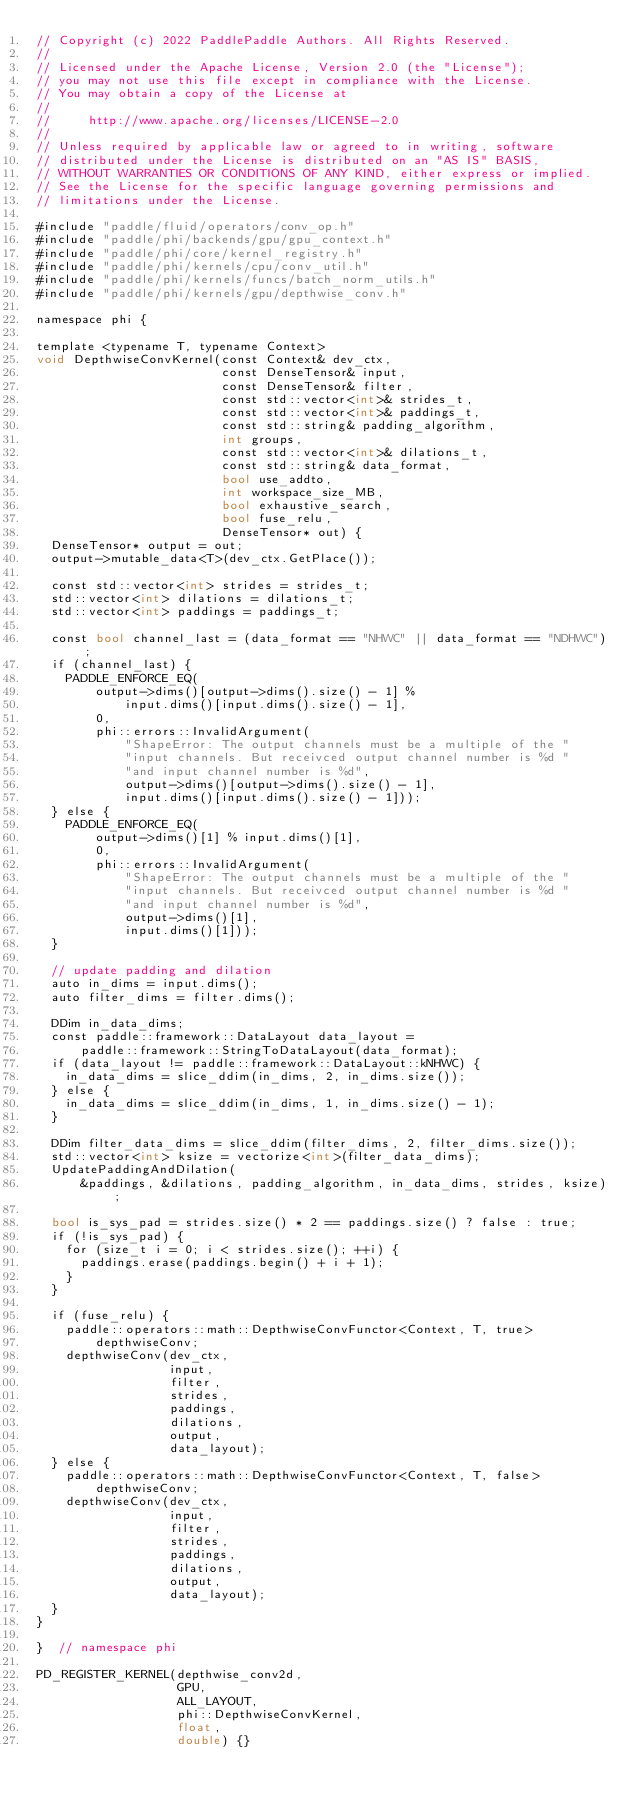<code> <loc_0><loc_0><loc_500><loc_500><_Cuda_>// Copyright (c) 2022 PaddlePaddle Authors. All Rights Reserved.
//
// Licensed under the Apache License, Version 2.0 (the "License");
// you may not use this file except in compliance with the License.
// You may obtain a copy of the License at
//
//     http://www.apache.org/licenses/LICENSE-2.0
//
// Unless required by applicable law or agreed to in writing, software
// distributed under the License is distributed on an "AS IS" BASIS,
// WITHOUT WARRANTIES OR CONDITIONS OF ANY KIND, either express or implied.
// See the License for the specific language governing permissions and
// limitations under the License.

#include "paddle/fluid/operators/conv_op.h"
#include "paddle/phi/backends/gpu/gpu_context.h"
#include "paddle/phi/core/kernel_registry.h"
#include "paddle/phi/kernels/cpu/conv_util.h"
#include "paddle/phi/kernels/funcs/batch_norm_utils.h"
#include "paddle/phi/kernels/gpu/depthwise_conv.h"

namespace phi {

template <typename T, typename Context>
void DepthwiseConvKernel(const Context& dev_ctx,
                         const DenseTensor& input,
                         const DenseTensor& filter,
                         const std::vector<int>& strides_t,
                         const std::vector<int>& paddings_t,
                         const std::string& padding_algorithm,
                         int groups,
                         const std::vector<int>& dilations_t,
                         const std::string& data_format,
                         bool use_addto,
                         int workspace_size_MB,
                         bool exhaustive_search,
                         bool fuse_relu,
                         DenseTensor* out) {
  DenseTensor* output = out;
  output->mutable_data<T>(dev_ctx.GetPlace());

  const std::vector<int> strides = strides_t;
  std::vector<int> dilations = dilations_t;
  std::vector<int> paddings = paddings_t;

  const bool channel_last = (data_format == "NHWC" || data_format == "NDHWC");
  if (channel_last) {
    PADDLE_ENFORCE_EQ(
        output->dims()[output->dims().size() - 1] %
            input.dims()[input.dims().size() - 1],
        0,
        phi::errors::InvalidArgument(
            "ShapeError: The output channels must be a multiple of the "
            "input channels. But receivced output channel number is %d "
            "and input channel number is %d",
            output->dims()[output->dims().size() - 1],
            input.dims()[input.dims().size() - 1]));
  } else {
    PADDLE_ENFORCE_EQ(
        output->dims()[1] % input.dims()[1],
        0,
        phi::errors::InvalidArgument(
            "ShapeError: The output channels must be a multiple of the "
            "input channels. But receivced output channel number is %d "
            "and input channel number is %d",
            output->dims()[1],
            input.dims()[1]));
  }

  // update padding and dilation
  auto in_dims = input.dims();
  auto filter_dims = filter.dims();

  DDim in_data_dims;
  const paddle::framework::DataLayout data_layout =
      paddle::framework::StringToDataLayout(data_format);
  if (data_layout != paddle::framework::DataLayout::kNHWC) {
    in_data_dims = slice_ddim(in_dims, 2, in_dims.size());
  } else {
    in_data_dims = slice_ddim(in_dims, 1, in_dims.size() - 1);
  }

  DDim filter_data_dims = slice_ddim(filter_dims, 2, filter_dims.size());
  std::vector<int> ksize = vectorize<int>(filter_data_dims);
  UpdatePaddingAndDilation(
      &paddings, &dilations, padding_algorithm, in_data_dims, strides, ksize);

  bool is_sys_pad = strides.size() * 2 == paddings.size() ? false : true;
  if (!is_sys_pad) {
    for (size_t i = 0; i < strides.size(); ++i) {
      paddings.erase(paddings.begin() + i + 1);
    }
  }

  if (fuse_relu) {
    paddle::operators::math::DepthwiseConvFunctor<Context, T, true>
        depthwiseConv;
    depthwiseConv(dev_ctx,
                  input,
                  filter,
                  strides,
                  paddings,
                  dilations,
                  output,
                  data_layout);
  } else {
    paddle::operators::math::DepthwiseConvFunctor<Context, T, false>
        depthwiseConv;
    depthwiseConv(dev_ctx,
                  input,
                  filter,
                  strides,
                  paddings,
                  dilations,
                  output,
                  data_layout);
  }
}

}  // namespace phi

PD_REGISTER_KERNEL(depthwise_conv2d,
                   GPU,
                   ALL_LAYOUT,
                   phi::DepthwiseConvKernel,
                   float,
                   double) {}
</code> 